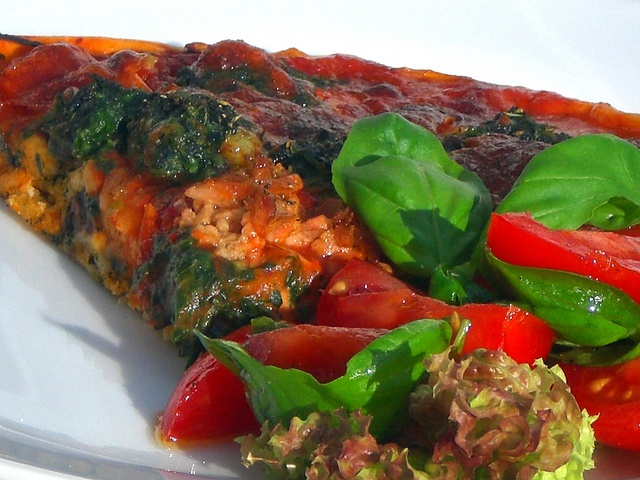Describe the objects in this image and their specific colors. I can see broccoli in white, black, darkgreen, and maroon tones, broccoli in white, black, darkgreen, and gray tones, and broccoli in white, black, and darkgreen tones in this image. 